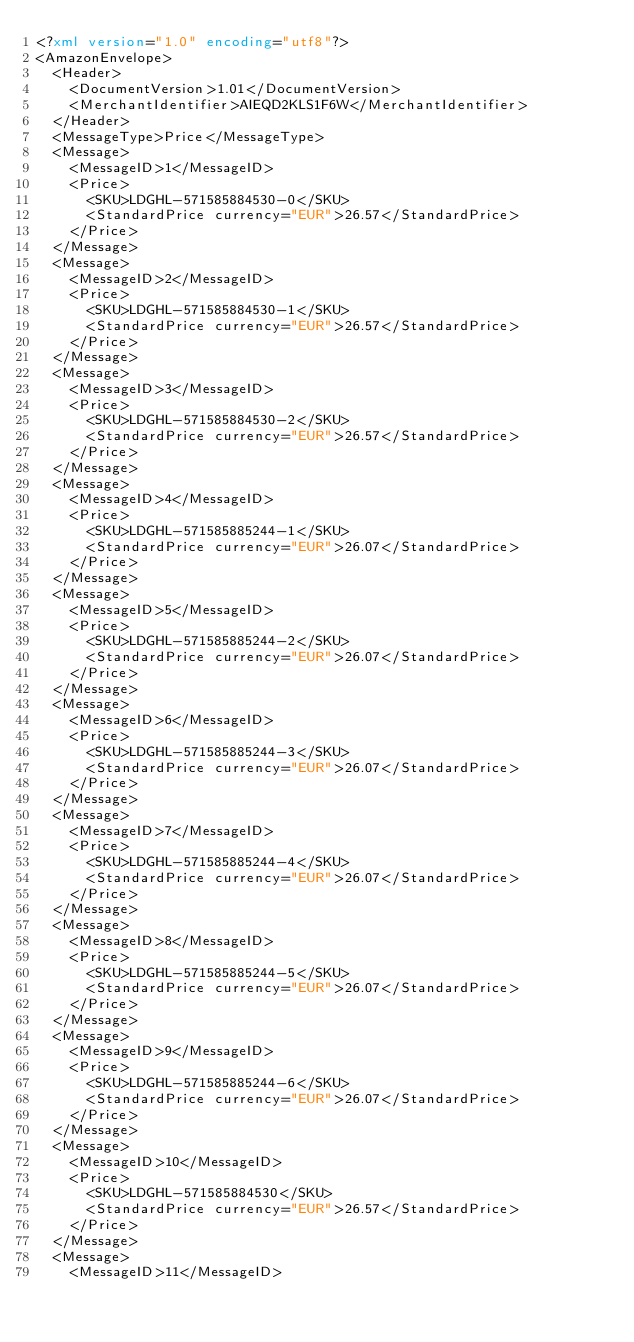<code> <loc_0><loc_0><loc_500><loc_500><_XML_><?xml version="1.0" encoding="utf8"?>
<AmazonEnvelope>
  <Header>
    <DocumentVersion>1.01</DocumentVersion>
    <MerchantIdentifier>AIEQD2KLS1F6W</MerchantIdentifier>
  </Header>
  <MessageType>Price</MessageType>
  <Message>
    <MessageID>1</MessageID>
    <Price>
      <SKU>LDGHL-571585884530-0</SKU>
      <StandardPrice currency="EUR">26.57</StandardPrice>
    </Price>
  </Message>
  <Message>
    <MessageID>2</MessageID>
    <Price>
      <SKU>LDGHL-571585884530-1</SKU>
      <StandardPrice currency="EUR">26.57</StandardPrice>
    </Price>
  </Message>
  <Message>
    <MessageID>3</MessageID>
    <Price>
      <SKU>LDGHL-571585884530-2</SKU>
      <StandardPrice currency="EUR">26.57</StandardPrice>
    </Price>
  </Message>
  <Message>
    <MessageID>4</MessageID>
    <Price>
      <SKU>LDGHL-571585885244-1</SKU>
      <StandardPrice currency="EUR">26.07</StandardPrice>
    </Price>
  </Message>
  <Message>
    <MessageID>5</MessageID>
    <Price>
      <SKU>LDGHL-571585885244-2</SKU>
      <StandardPrice currency="EUR">26.07</StandardPrice>
    </Price>
  </Message>
  <Message>
    <MessageID>6</MessageID>
    <Price>
      <SKU>LDGHL-571585885244-3</SKU>
      <StandardPrice currency="EUR">26.07</StandardPrice>
    </Price>
  </Message>
  <Message>
    <MessageID>7</MessageID>
    <Price>
      <SKU>LDGHL-571585885244-4</SKU>
      <StandardPrice currency="EUR">26.07</StandardPrice>
    </Price>
  </Message>
  <Message>
    <MessageID>8</MessageID>
    <Price>
      <SKU>LDGHL-571585885244-5</SKU>
      <StandardPrice currency="EUR">26.07</StandardPrice>
    </Price>
  </Message>
  <Message>
    <MessageID>9</MessageID>
    <Price>
      <SKU>LDGHL-571585885244-6</SKU>
      <StandardPrice currency="EUR">26.07</StandardPrice>
    </Price>
  </Message>
  <Message>
    <MessageID>10</MessageID>
    <Price>
      <SKU>LDGHL-571585884530</SKU>
      <StandardPrice currency="EUR">26.57</StandardPrice>
    </Price>
  </Message>
  <Message>
    <MessageID>11</MessageID></code> 